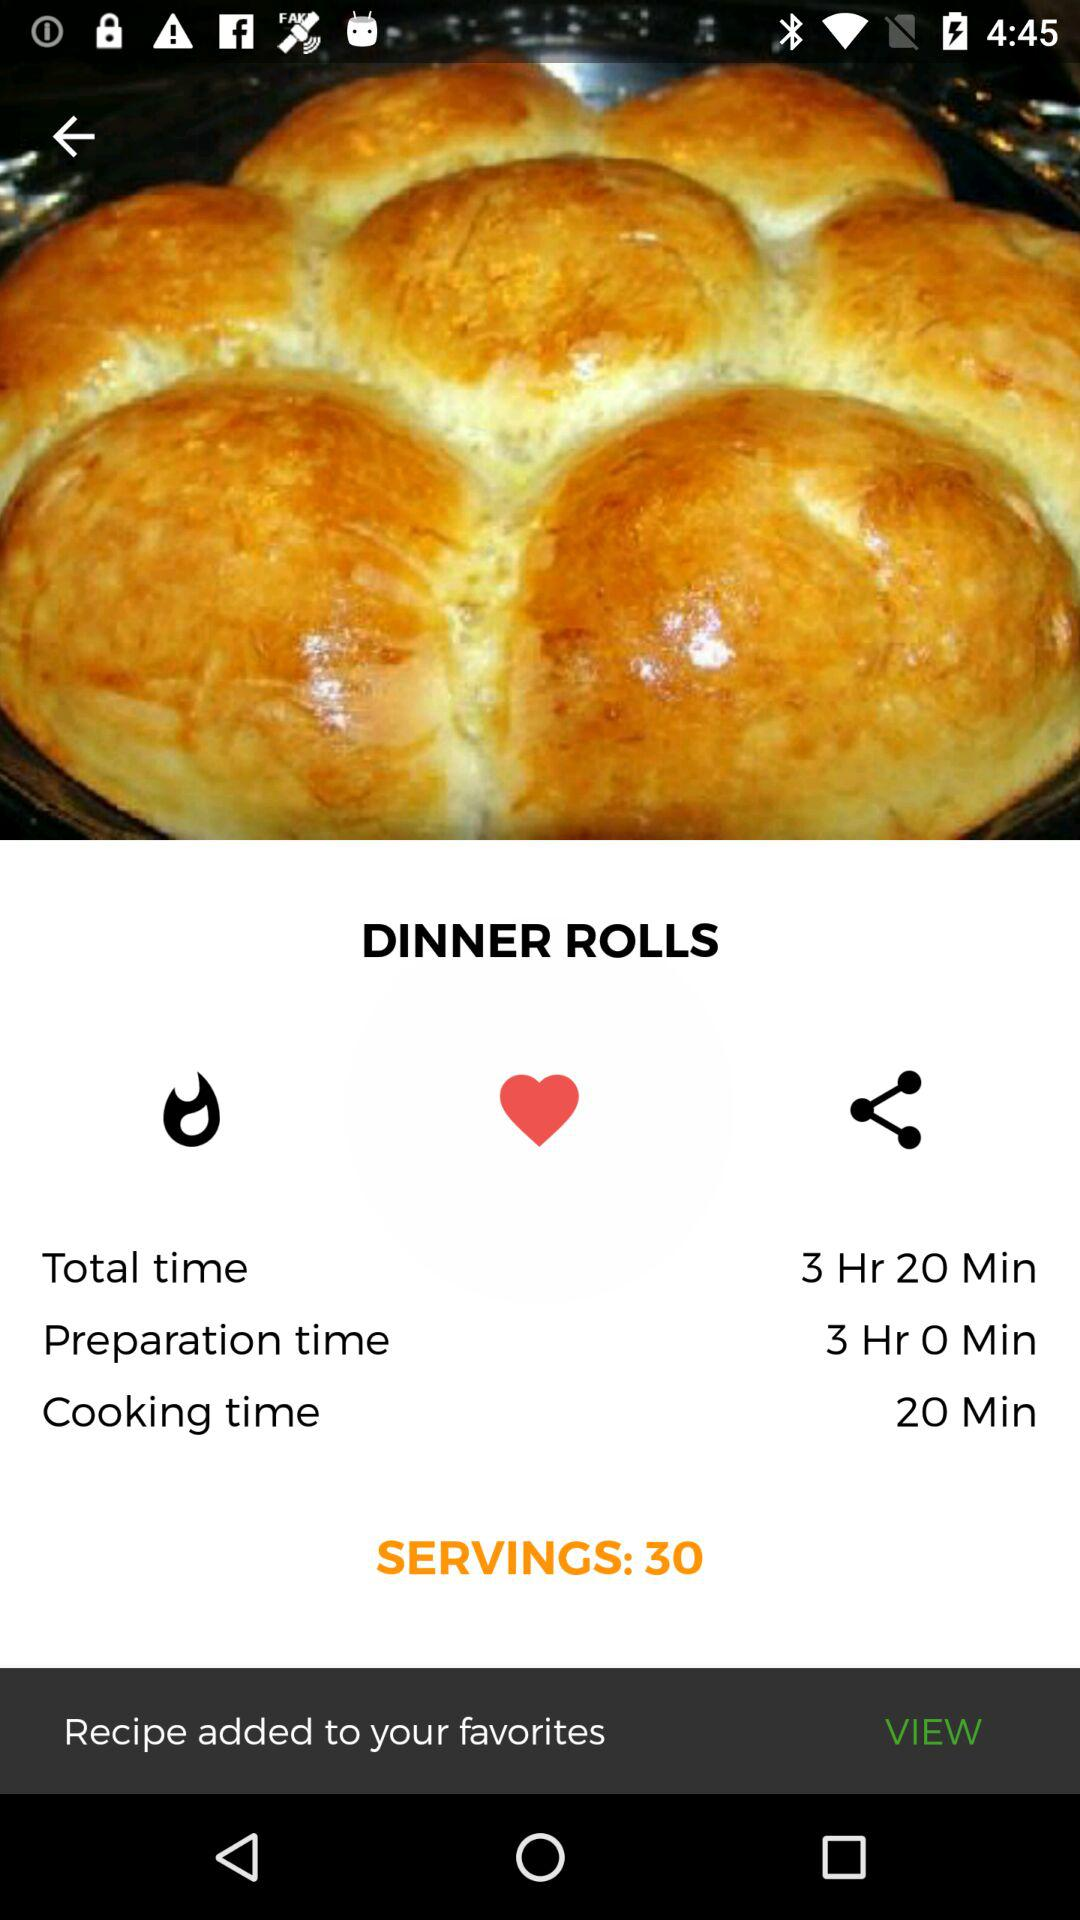How many people can be served? The number of people who can be served is 30. 